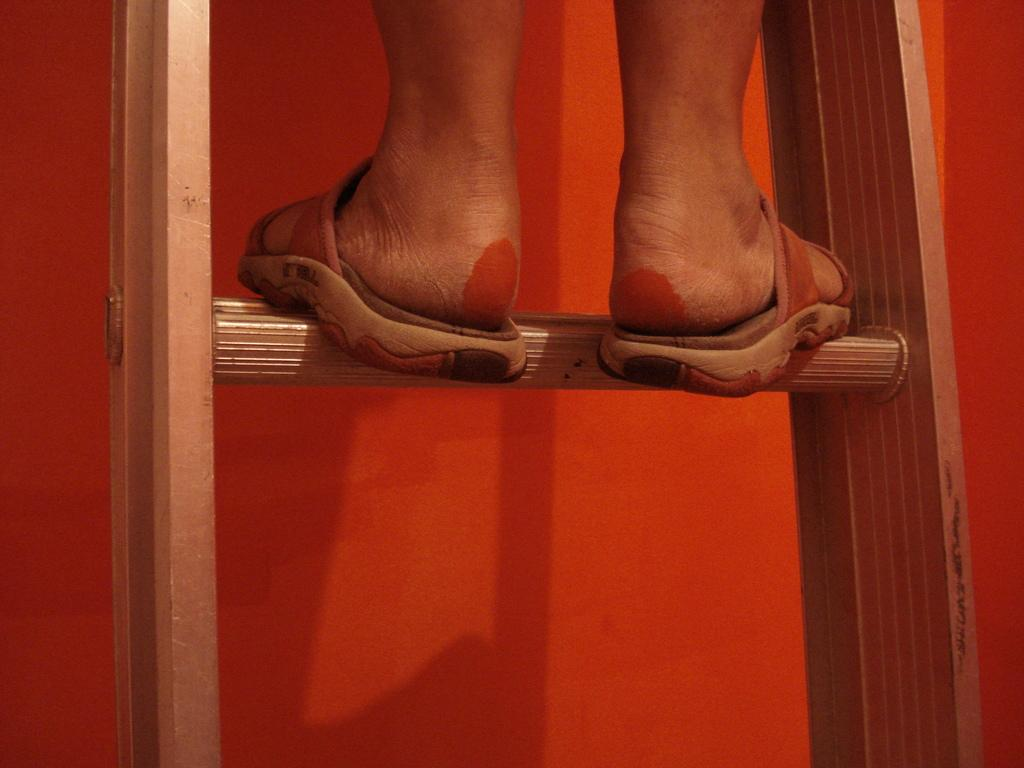What is the person in the image doing? The person in the image is standing on a ladder. What can be seen in the background of the image? There is a red color wall in the background of the image. What type of button is the person holding in their hand in the image? There is no button present in the image, and the person is not holding anything in their hand. 